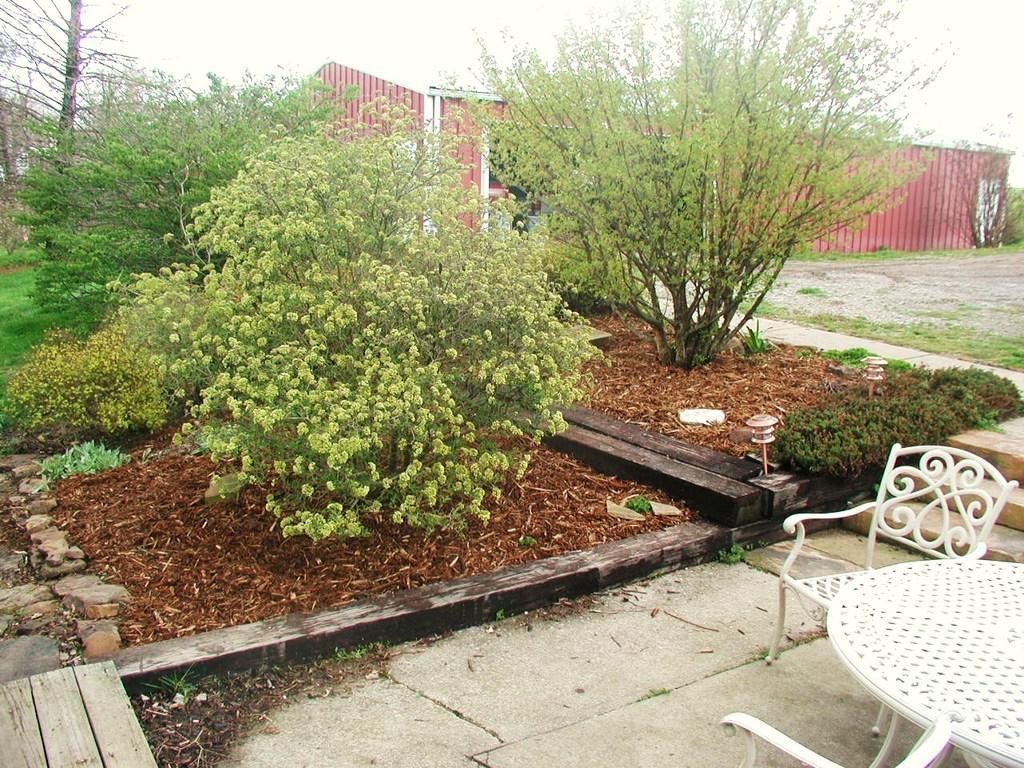Can you describe this image briefly? In the foreground of the picture, there is a table and two chairs on the right side. We can also see trees and plants in the middle. In the background, there is a shed and at the top, there is the sky. 